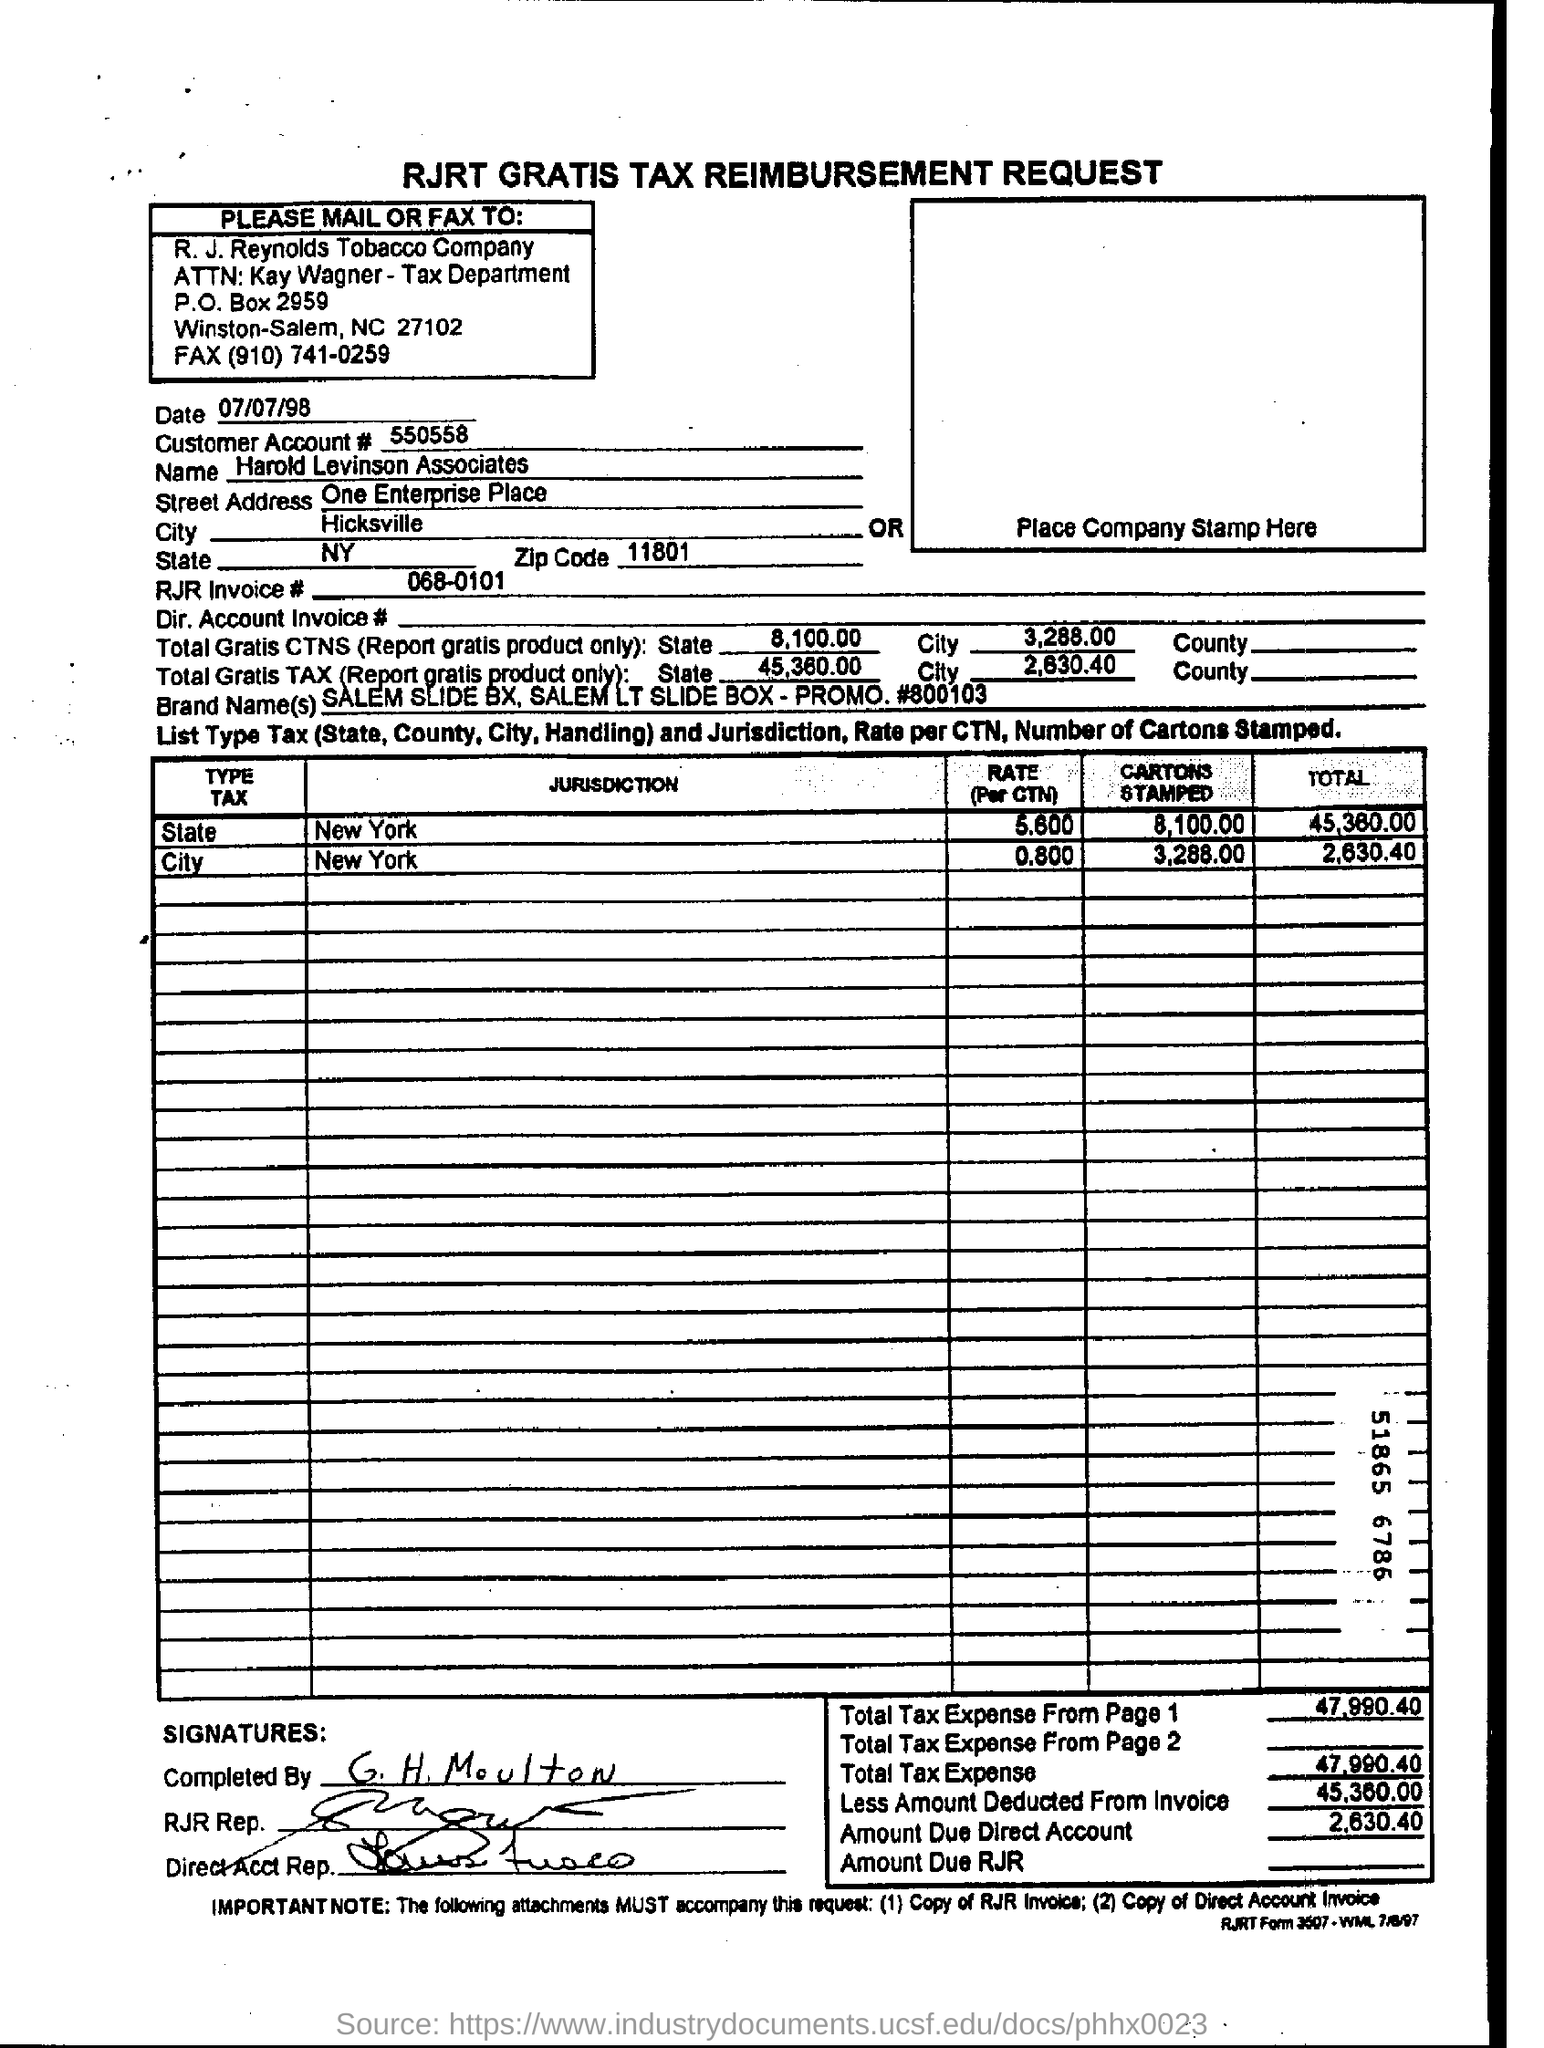Give some essential details in this illustration. The RJR invoice number is 068-0101. The date mentioned is July 7th, 1998. The name of the company entered in the form is Harold Levinson Associates. The customer account number is 550558. 